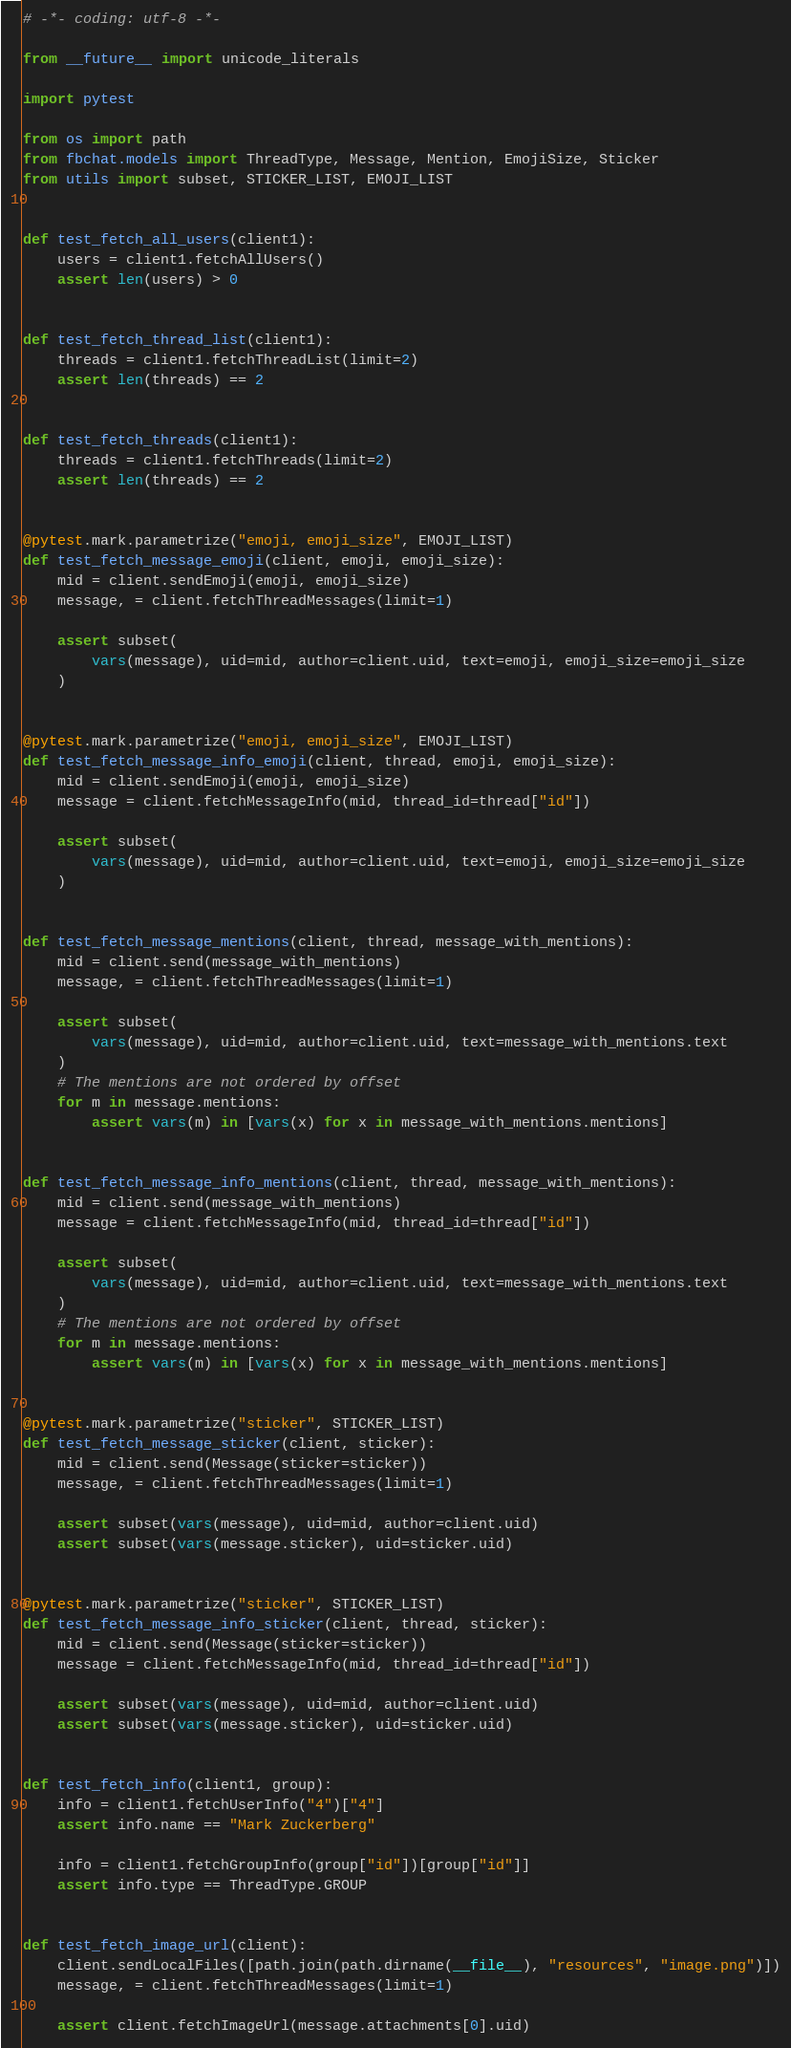<code> <loc_0><loc_0><loc_500><loc_500><_Python_># -*- coding: utf-8 -*-

from __future__ import unicode_literals

import pytest

from os import path
from fbchat.models import ThreadType, Message, Mention, EmojiSize, Sticker
from utils import subset, STICKER_LIST, EMOJI_LIST


def test_fetch_all_users(client1):
    users = client1.fetchAllUsers()
    assert len(users) > 0


def test_fetch_thread_list(client1):
    threads = client1.fetchThreadList(limit=2)
    assert len(threads) == 2


def test_fetch_threads(client1):
    threads = client1.fetchThreads(limit=2)
    assert len(threads) == 2


@pytest.mark.parametrize("emoji, emoji_size", EMOJI_LIST)
def test_fetch_message_emoji(client, emoji, emoji_size):
    mid = client.sendEmoji(emoji, emoji_size)
    message, = client.fetchThreadMessages(limit=1)

    assert subset(
        vars(message), uid=mid, author=client.uid, text=emoji, emoji_size=emoji_size
    )


@pytest.mark.parametrize("emoji, emoji_size", EMOJI_LIST)
def test_fetch_message_info_emoji(client, thread, emoji, emoji_size):
    mid = client.sendEmoji(emoji, emoji_size)
    message = client.fetchMessageInfo(mid, thread_id=thread["id"])

    assert subset(
        vars(message), uid=mid, author=client.uid, text=emoji, emoji_size=emoji_size
    )


def test_fetch_message_mentions(client, thread, message_with_mentions):
    mid = client.send(message_with_mentions)
    message, = client.fetchThreadMessages(limit=1)

    assert subset(
        vars(message), uid=mid, author=client.uid, text=message_with_mentions.text
    )
    # The mentions are not ordered by offset
    for m in message.mentions:
        assert vars(m) in [vars(x) for x in message_with_mentions.mentions]


def test_fetch_message_info_mentions(client, thread, message_with_mentions):
    mid = client.send(message_with_mentions)
    message = client.fetchMessageInfo(mid, thread_id=thread["id"])

    assert subset(
        vars(message), uid=mid, author=client.uid, text=message_with_mentions.text
    )
    # The mentions are not ordered by offset
    for m in message.mentions:
        assert vars(m) in [vars(x) for x in message_with_mentions.mentions]


@pytest.mark.parametrize("sticker", STICKER_LIST)
def test_fetch_message_sticker(client, sticker):
    mid = client.send(Message(sticker=sticker))
    message, = client.fetchThreadMessages(limit=1)

    assert subset(vars(message), uid=mid, author=client.uid)
    assert subset(vars(message.sticker), uid=sticker.uid)


@pytest.mark.parametrize("sticker", STICKER_LIST)
def test_fetch_message_info_sticker(client, thread, sticker):
    mid = client.send(Message(sticker=sticker))
    message = client.fetchMessageInfo(mid, thread_id=thread["id"])

    assert subset(vars(message), uid=mid, author=client.uid)
    assert subset(vars(message.sticker), uid=sticker.uid)


def test_fetch_info(client1, group):
    info = client1.fetchUserInfo("4")["4"]
    assert info.name == "Mark Zuckerberg"

    info = client1.fetchGroupInfo(group["id"])[group["id"]]
    assert info.type == ThreadType.GROUP


def test_fetch_image_url(client):
    client.sendLocalFiles([path.join(path.dirname(__file__), "resources", "image.png")])
    message, = client.fetchThreadMessages(limit=1)

    assert client.fetchImageUrl(message.attachments[0].uid)
</code> 